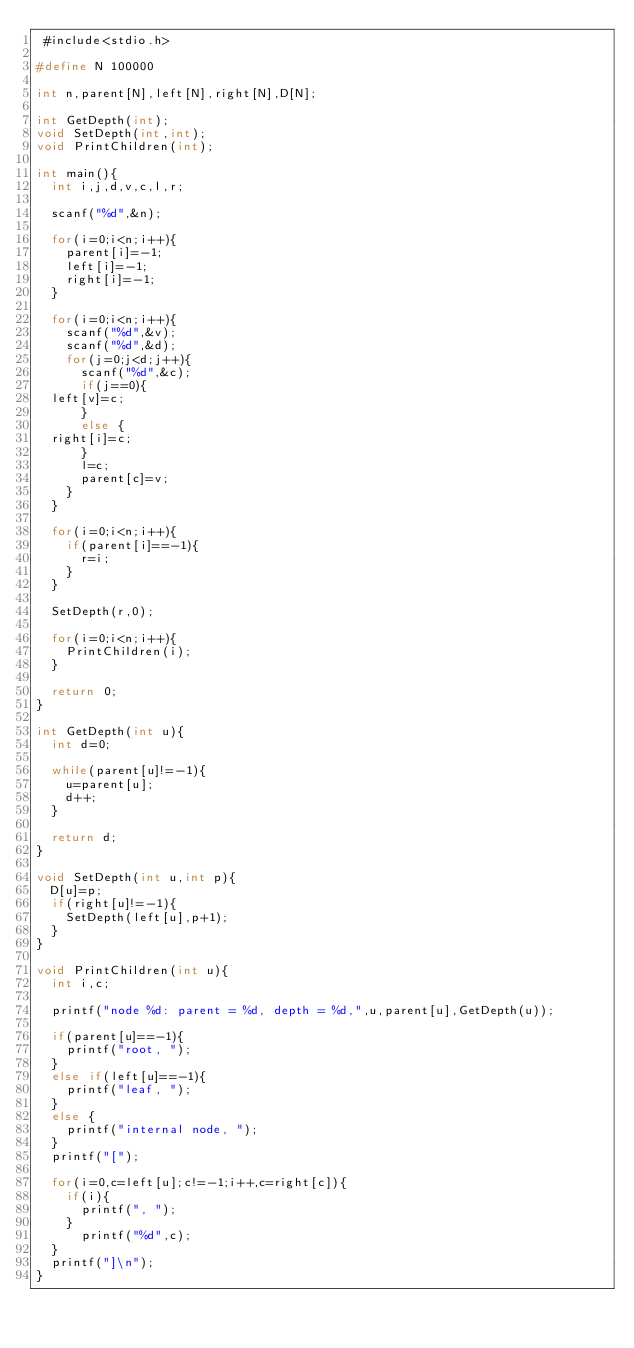Convert code to text. <code><loc_0><loc_0><loc_500><loc_500><_C_> #include<stdio.h>

#define N 100000

int n,parent[N],left[N],right[N],D[N];

int GetDepth(int);
void SetDepth(int,int);
void PrintChildren(int);

int main(){
  int i,j,d,v,c,l,r;

  scanf("%d",&n);

  for(i=0;i<n;i++){
    parent[i]=-1;
    left[i]=-1;
    right[i]=-1;
  }

  for(i=0;i<n;i++){
    scanf("%d",&v);
    scanf("%d",&d);
    for(j=0;j<d;j++){
      scanf("%d",&c);
      if(j==0){
	left[v]=c;
      }
      else {
	right[i]=c;
      }
      l=c;
      parent[c]=v;
    }
  }

  for(i=0;i<n;i++){
    if(parent[i]==-1){
      r=i;
    }
  }

  SetDepth(r,0);

  for(i=0;i<n;i++){
    PrintChildren(i);
  }

  return 0;
}

int GetDepth(int u){
  int d=0;

  while(parent[u]!=-1){
    u=parent[u];
    d++;
  }

  return d;
}

void SetDepth(int u,int p){
  D[u]=p;
  if(right[u]!=-1){
    SetDepth(left[u],p+1);
  }
}

void PrintChildren(int u){
  int i,c;

  printf("node %d: parent = %d, depth = %d,",u,parent[u],GetDepth(u));
  
  if(parent[u]==-1){
    printf("root, ");
  }
  else if(left[u]==-1){
    printf("leaf, ");
  }
  else {
    printf("internal node, ");
  }
  printf("[");

  for(i=0,c=left[u];c!=-1;i++,c=right[c]){
    if(i){
      printf(", ");
    }
      printf("%d",c);
  }
  printf("]\n");
}

  
     
    
    

</code> 